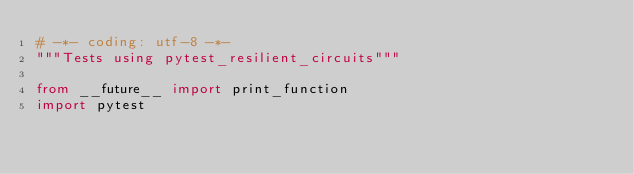<code> <loc_0><loc_0><loc_500><loc_500><_Python_># -*- coding: utf-8 -*-
"""Tests using pytest_resilient_circuits"""

from __future__ import print_function
import pytest</code> 